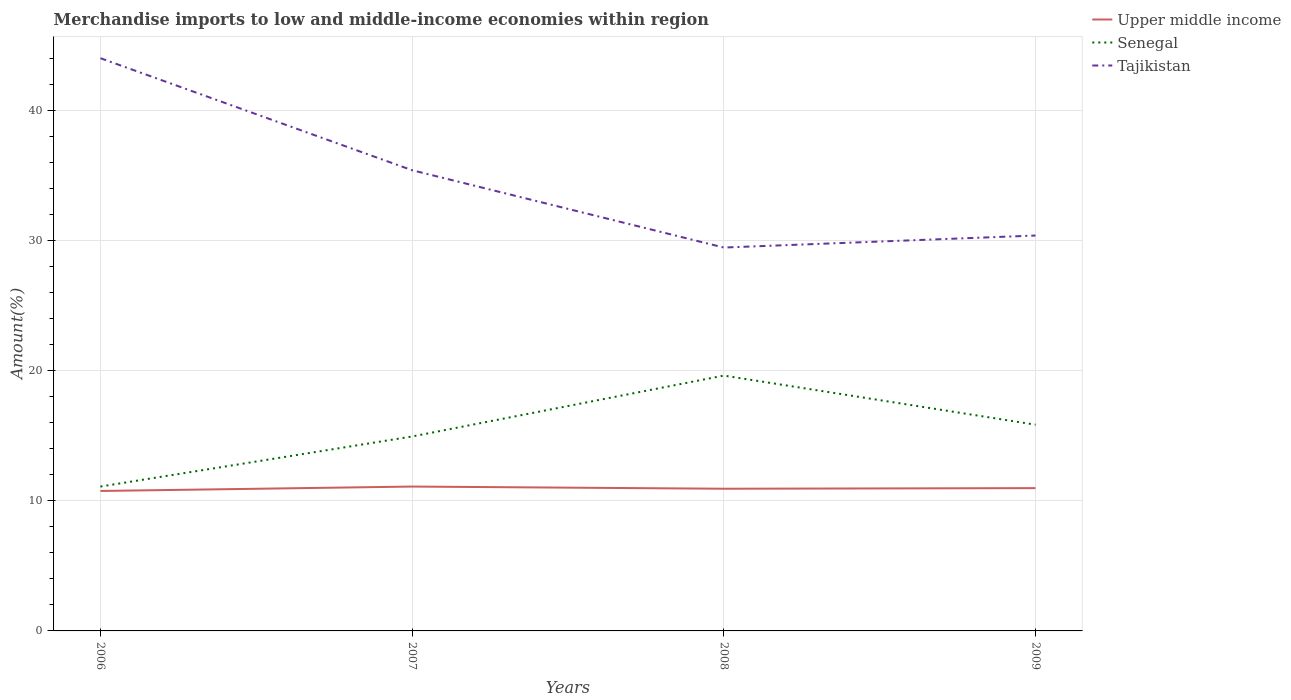How many different coloured lines are there?
Offer a terse response. 3. Does the line corresponding to Senegal intersect with the line corresponding to Upper middle income?
Provide a short and direct response. No. Is the number of lines equal to the number of legend labels?
Ensure brevity in your answer.  Yes. Across all years, what is the maximum percentage of amount earned from merchandise imports in Tajikistan?
Provide a short and direct response. 29.48. What is the total percentage of amount earned from merchandise imports in Senegal in the graph?
Provide a short and direct response. 3.78. What is the difference between the highest and the second highest percentage of amount earned from merchandise imports in Senegal?
Keep it short and to the point. 8.53. Is the percentage of amount earned from merchandise imports in Tajikistan strictly greater than the percentage of amount earned from merchandise imports in Senegal over the years?
Offer a very short reply. No. How many lines are there?
Offer a terse response. 3. How many years are there in the graph?
Provide a short and direct response. 4. Are the values on the major ticks of Y-axis written in scientific E-notation?
Provide a short and direct response. No. Does the graph contain any zero values?
Make the answer very short. No. Does the graph contain grids?
Your answer should be very brief. Yes. Where does the legend appear in the graph?
Provide a short and direct response. Top right. What is the title of the graph?
Offer a very short reply. Merchandise imports to low and middle-income economies within region. What is the label or title of the X-axis?
Provide a succinct answer. Years. What is the label or title of the Y-axis?
Ensure brevity in your answer.  Amount(%). What is the Amount(%) in Upper middle income in 2006?
Your answer should be compact. 10.76. What is the Amount(%) of Senegal in 2006?
Offer a very short reply. 11.1. What is the Amount(%) of Tajikistan in 2006?
Provide a succinct answer. 44.04. What is the Amount(%) in Upper middle income in 2007?
Your response must be concise. 11.1. What is the Amount(%) in Senegal in 2007?
Your answer should be very brief. 14.95. What is the Amount(%) in Tajikistan in 2007?
Make the answer very short. 35.43. What is the Amount(%) of Upper middle income in 2008?
Your response must be concise. 10.93. What is the Amount(%) of Senegal in 2008?
Keep it short and to the point. 19.64. What is the Amount(%) in Tajikistan in 2008?
Your answer should be compact. 29.48. What is the Amount(%) in Upper middle income in 2009?
Provide a short and direct response. 10.98. What is the Amount(%) in Senegal in 2009?
Provide a short and direct response. 15.86. What is the Amount(%) in Tajikistan in 2009?
Provide a succinct answer. 30.41. Across all years, what is the maximum Amount(%) in Upper middle income?
Offer a very short reply. 11.1. Across all years, what is the maximum Amount(%) of Senegal?
Provide a short and direct response. 19.64. Across all years, what is the maximum Amount(%) in Tajikistan?
Ensure brevity in your answer.  44.04. Across all years, what is the minimum Amount(%) in Upper middle income?
Your answer should be compact. 10.76. Across all years, what is the minimum Amount(%) of Senegal?
Provide a succinct answer. 11.1. Across all years, what is the minimum Amount(%) in Tajikistan?
Provide a succinct answer. 29.48. What is the total Amount(%) in Upper middle income in the graph?
Offer a very short reply. 43.78. What is the total Amount(%) in Senegal in the graph?
Your answer should be very brief. 61.55. What is the total Amount(%) of Tajikistan in the graph?
Your response must be concise. 139.36. What is the difference between the Amount(%) of Upper middle income in 2006 and that in 2007?
Provide a short and direct response. -0.34. What is the difference between the Amount(%) in Senegal in 2006 and that in 2007?
Provide a succinct answer. -3.85. What is the difference between the Amount(%) of Tajikistan in 2006 and that in 2007?
Offer a terse response. 8.61. What is the difference between the Amount(%) of Upper middle income in 2006 and that in 2008?
Offer a very short reply. -0.17. What is the difference between the Amount(%) in Senegal in 2006 and that in 2008?
Make the answer very short. -8.53. What is the difference between the Amount(%) in Tajikistan in 2006 and that in 2008?
Your response must be concise. 14.56. What is the difference between the Amount(%) of Upper middle income in 2006 and that in 2009?
Keep it short and to the point. -0.22. What is the difference between the Amount(%) in Senegal in 2006 and that in 2009?
Your answer should be very brief. -4.76. What is the difference between the Amount(%) in Tajikistan in 2006 and that in 2009?
Make the answer very short. 13.64. What is the difference between the Amount(%) in Upper middle income in 2007 and that in 2008?
Provide a short and direct response. 0.17. What is the difference between the Amount(%) in Senegal in 2007 and that in 2008?
Your answer should be very brief. -4.68. What is the difference between the Amount(%) of Tajikistan in 2007 and that in 2008?
Give a very brief answer. 5.95. What is the difference between the Amount(%) of Upper middle income in 2007 and that in 2009?
Provide a short and direct response. 0.12. What is the difference between the Amount(%) of Senegal in 2007 and that in 2009?
Offer a very short reply. -0.91. What is the difference between the Amount(%) in Tajikistan in 2007 and that in 2009?
Ensure brevity in your answer.  5.02. What is the difference between the Amount(%) of Upper middle income in 2008 and that in 2009?
Give a very brief answer. -0.05. What is the difference between the Amount(%) of Senegal in 2008 and that in 2009?
Give a very brief answer. 3.78. What is the difference between the Amount(%) in Tajikistan in 2008 and that in 2009?
Give a very brief answer. -0.92. What is the difference between the Amount(%) in Upper middle income in 2006 and the Amount(%) in Senegal in 2007?
Your response must be concise. -4.19. What is the difference between the Amount(%) of Upper middle income in 2006 and the Amount(%) of Tajikistan in 2007?
Ensure brevity in your answer.  -24.66. What is the difference between the Amount(%) in Senegal in 2006 and the Amount(%) in Tajikistan in 2007?
Offer a very short reply. -24.32. What is the difference between the Amount(%) of Upper middle income in 2006 and the Amount(%) of Senegal in 2008?
Provide a short and direct response. -8.87. What is the difference between the Amount(%) in Upper middle income in 2006 and the Amount(%) in Tajikistan in 2008?
Your answer should be very brief. -18.72. What is the difference between the Amount(%) of Senegal in 2006 and the Amount(%) of Tajikistan in 2008?
Offer a very short reply. -18.38. What is the difference between the Amount(%) in Upper middle income in 2006 and the Amount(%) in Senegal in 2009?
Give a very brief answer. -5.1. What is the difference between the Amount(%) in Upper middle income in 2006 and the Amount(%) in Tajikistan in 2009?
Your answer should be very brief. -19.64. What is the difference between the Amount(%) of Senegal in 2006 and the Amount(%) of Tajikistan in 2009?
Your answer should be very brief. -19.3. What is the difference between the Amount(%) in Upper middle income in 2007 and the Amount(%) in Senegal in 2008?
Your response must be concise. -8.53. What is the difference between the Amount(%) of Upper middle income in 2007 and the Amount(%) of Tajikistan in 2008?
Offer a terse response. -18.38. What is the difference between the Amount(%) in Senegal in 2007 and the Amount(%) in Tajikistan in 2008?
Make the answer very short. -14.53. What is the difference between the Amount(%) of Upper middle income in 2007 and the Amount(%) of Senegal in 2009?
Your response must be concise. -4.76. What is the difference between the Amount(%) of Upper middle income in 2007 and the Amount(%) of Tajikistan in 2009?
Provide a succinct answer. -19.31. What is the difference between the Amount(%) of Senegal in 2007 and the Amount(%) of Tajikistan in 2009?
Your answer should be very brief. -15.45. What is the difference between the Amount(%) in Upper middle income in 2008 and the Amount(%) in Senegal in 2009?
Give a very brief answer. -4.93. What is the difference between the Amount(%) in Upper middle income in 2008 and the Amount(%) in Tajikistan in 2009?
Ensure brevity in your answer.  -19.47. What is the difference between the Amount(%) in Senegal in 2008 and the Amount(%) in Tajikistan in 2009?
Your response must be concise. -10.77. What is the average Amount(%) in Upper middle income per year?
Provide a short and direct response. 10.94. What is the average Amount(%) of Senegal per year?
Provide a short and direct response. 15.39. What is the average Amount(%) in Tajikistan per year?
Ensure brevity in your answer.  34.84. In the year 2006, what is the difference between the Amount(%) of Upper middle income and Amount(%) of Senegal?
Ensure brevity in your answer.  -0.34. In the year 2006, what is the difference between the Amount(%) in Upper middle income and Amount(%) in Tajikistan?
Make the answer very short. -33.28. In the year 2006, what is the difference between the Amount(%) of Senegal and Amount(%) of Tajikistan?
Provide a succinct answer. -32.94. In the year 2007, what is the difference between the Amount(%) in Upper middle income and Amount(%) in Senegal?
Offer a terse response. -3.85. In the year 2007, what is the difference between the Amount(%) in Upper middle income and Amount(%) in Tajikistan?
Keep it short and to the point. -24.33. In the year 2007, what is the difference between the Amount(%) in Senegal and Amount(%) in Tajikistan?
Provide a short and direct response. -20.47. In the year 2008, what is the difference between the Amount(%) of Upper middle income and Amount(%) of Senegal?
Provide a succinct answer. -8.7. In the year 2008, what is the difference between the Amount(%) of Upper middle income and Amount(%) of Tajikistan?
Your answer should be very brief. -18.55. In the year 2008, what is the difference between the Amount(%) in Senegal and Amount(%) in Tajikistan?
Offer a very short reply. -9.85. In the year 2009, what is the difference between the Amount(%) of Upper middle income and Amount(%) of Senegal?
Make the answer very short. -4.88. In the year 2009, what is the difference between the Amount(%) of Upper middle income and Amount(%) of Tajikistan?
Keep it short and to the point. -19.43. In the year 2009, what is the difference between the Amount(%) in Senegal and Amount(%) in Tajikistan?
Provide a succinct answer. -14.55. What is the ratio of the Amount(%) in Upper middle income in 2006 to that in 2007?
Your answer should be very brief. 0.97. What is the ratio of the Amount(%) of Senegal in 2006 to that in 2007?
Make the answer very short. 0.74. What is the ratio of the Amount(%) of Tajikistan in 2006 to that in 2007?
Ensure brevity in your answer.  1.24. What is the ratio of the Amount(%) of Upper middle income in 2006 to that in 2008?
Your answer should be compact. 0.98. What is the ratio of the Amount(%) of Senegal in 2006 to that in 2008?
Offer a very short reply. 0.57. What is the ratio of the Amount(%) in Tajikistan in 2006 to that in 2008?
Offer a terse response. 1.49. What is the ratio of the Amount(%) in Upper middle income in 2006 to that in 2009?
Ensure brevity in your answer.  0.98. What is the ratio of the Amount(%) of Senegal in 2006 to that in 2009?
Keep it short and to the point. 0.7. What is the ratio of the Amount(%) in Tajikistan in 2006 to that in 2009?
Give a very brief answer. 1.45. What is the ratio of the Amount(%) in Upper middle income in 2007 to that in 2008?
Make the answer very short. 1.02. What is the ratio of the Amount(%) of Senegal in 2007 to that in 2008?
Give a very brief answer. 0.76. What is the ratio of the Amount(%) of Tajikistan in 2007 to that in 2008?
Offer a very short reply. 1.2. What is the ratio of the Amount(%) of Senegal in 2007 to that in 2009?
Keep it short and to the point. 0.94. What is the ratio of the Amount(%) of Tajikistan in 2007 to that in 2009?
Your answer should be compact. 1.17. What is the ratio of the Amount(%) in Upper middle income in 2008 to that in 2009?
Keep it short and to the point. 1. What is the ratio of the Amount(%) of Senegal in 2008 to that in 2009?
Your answer should be compact. 1.24. What is the ratio of the Amount(%) in Tajikistan in 2008 to that in 2009?
Your answer should be compact. 0.97. What is the difference between the highest and the second highest Amount(%) in Upper middle income?
Your answer should be compact. 0.12. What is the difference between the highest and the second highest Amount(%) in Senegal?
Offer a terse response. 3.78. What is the difference between the highest and the second highest Amount(%) in Tajikistan?
Give a very brief answer. 8.61. What is the difference between the highest and the lowest Amount(%) in Upper middle income?
Keep it short and to the point. 0.34. What is the difference between the highest and the lowest Amount(%) in Senegal?
Offer a very short reply. 8.53. What is the difference between the highest and the lowest Amount(%) in Tajikistan?
Your answer should be compact. 14.56. 